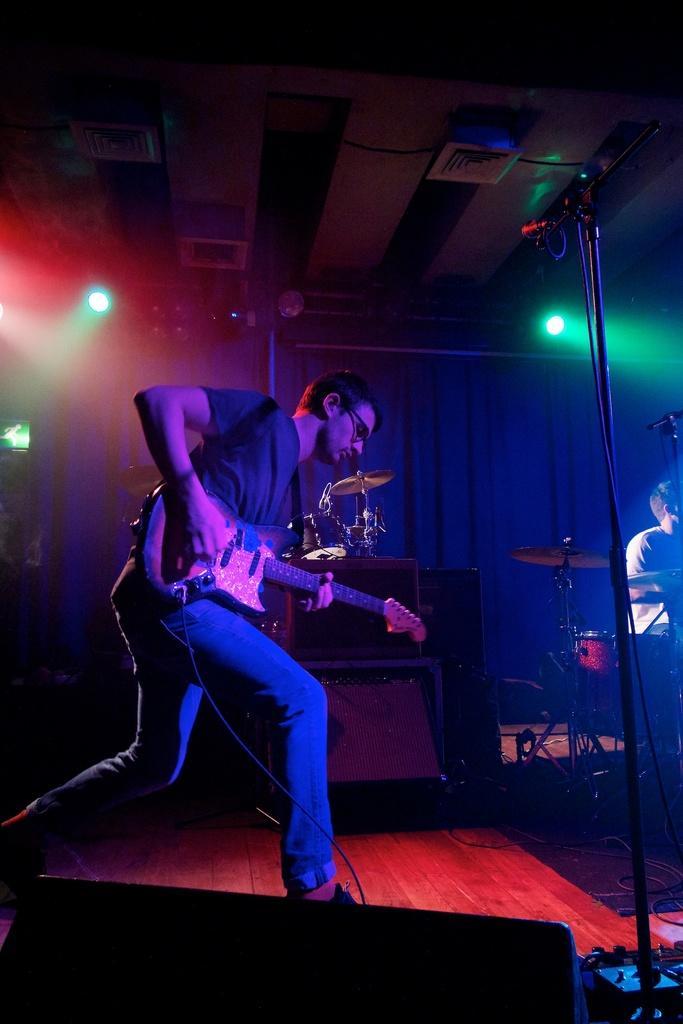Could you give a brief overview of what you see in this image? In this image i can see a man standing and holding guitar at the back ground i can see a curtain 